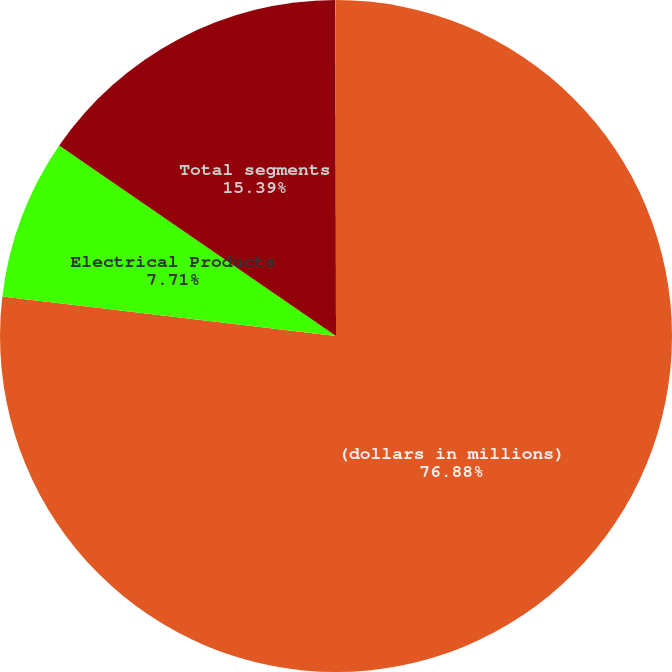Convert chart. <chart><loc_0><loc_0><loc_500><loc_500><pie_chart><fcel>(dollars in millions)<fcel>Electrical Products<fcel>Total segments<fcel>Corporate assets<nl><fcel>76.88%<fcel>7.71%<fcel>15.39%<fcel>0.02%<nl></chart> 